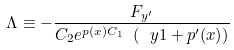Convert formula to latex. <formula><loc_0><loc_0><loc_500><loc_500>\Lambda \equiv - \frac { F _ { y ^ { \prime } } } { C _ { 2 } e ^ { p ( x ) C _ { 1 } } \ ( \ y 1 + p ^ { \prime } ( x ) ) }</formula> 